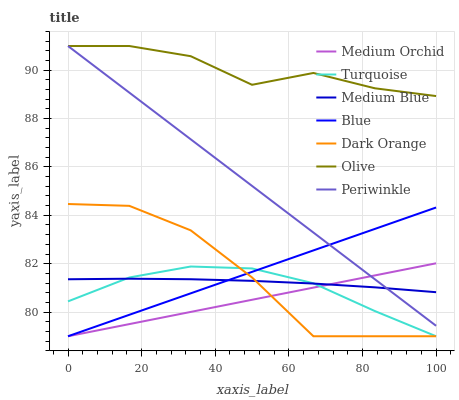Does Medium Orchid have the minimum area under the curve?
Answer yes or no. Yes. Does Olive have the maximum area under the curve?
Answer yes or no. Yes. Does Dark Orange have the minimum area under the curve?
Answer yes or no. No. Does Dark Orange have the maximum area under the curve?
Answer yes or no. No. Is Medium Orchid the smoothest?
Answer yes or no. Yes. Is Dark Orange the roughest?
Answer yes or no. Yes. Is Turquoise the smoothest?
Answer yes or no. No. Is Turquoise the roughest?
Answer yes or no. No. Does Blue have the lowest value?
Answer yes or no. Yes. Does Medium Blue have the lowest value?
Answer yes or no. No. Does Olive have the highest value?
Answer yes or no. Yes. Does Dark Orange have the highest value?
Answer yes or no. No. Is Turquoise less than Periwinkle?
Answer yes or no. Yes. Is Olive greater than Turquoise?
Answer yes or no. Yes. Does Periwinkle intersect Olive?
Answer yes or no. Yes. Is Periwinkle less than Olive?
Answer yes or no. No. Is Periwinkle greater than Olive?
Answer yes or no. No. Does Turquoise intersect Periwinkle?
Answer yes or no. No. 